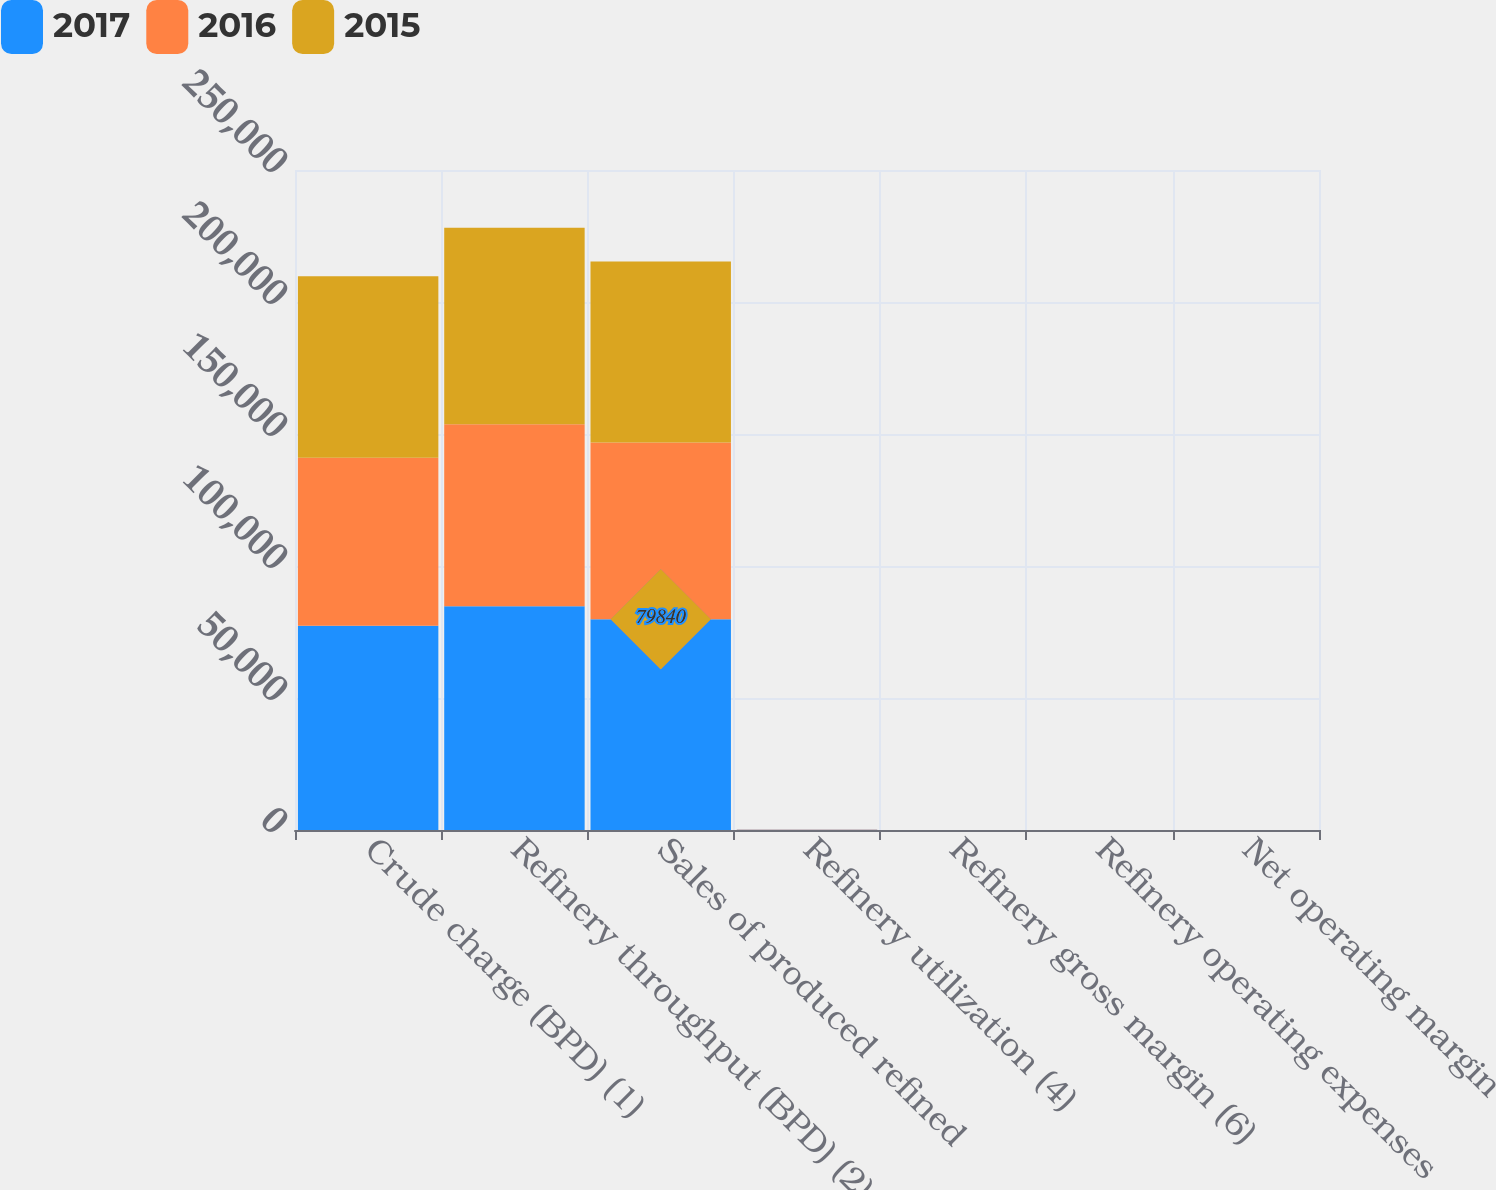Convert chart to OTSL. <chart><loc_0><loc_0><loc_500><loc_500><stacked_bar_chart><ecel><fcel>Crude charge (BPD) (1)<fcel>Refinery throughput (BPD) (2)<fcel>Sales of produced refined<fcel>Refinery utilization (4)<fcel>Refinery gross margin (6)<fcel>Refinery operating expenses<fcel>Net operating margin<nl><fcel>2017<fcel>77380<fcel>84790<fcel>79840<fcel>79.8<fcel>15.78<fcel>9.85<fcel>5.32<nl><fcel>2016<fcel>63650<fcel>68870<fcel>66950<fcel>65.6<fcel>8.8<fcel>9.89<fcel>1.37<nl><fcel>2015<fcel>68770<fcel>74480<fcel>68570<fcel>82.9<fcel>18.43<fcel>9.12<fcel>8.53<nl></chart> 